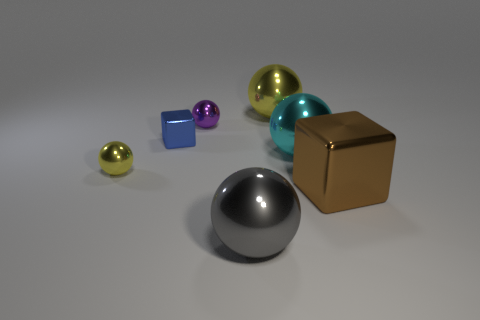The small ball in front of the metal cube left of the purple ball is what color?
Give a very brief answer. Yellow. How many other objects are there of the same material as the big gray object?
Your answer should be very brief. 6. What number of shiny things are small brown cylinders or balls?
Provide a short and direct response. 5. The other shiny object that is the same shape as the blue object is what color?
Your answer should be compact. Brown. How many objects are either small blue objects or big yellow metal things?
Your answer should be very brief. 2. What shape is the cyan thing that is the same material as the big gray sphere?
Provide a short and direct response. Sphere. What number of large objects are either blue spheres or blue metal things?
Your answer should be very brief. 0. How many other objects are the same color as the big metallic block?
Offer a terse response. 0. How many gray metal spheres are left of the metal block that is to the right of the shiny thing that is in front of the brown cube?
Make the answer very short. 1. There is a metal ball that is in front of the brown metallic cube; is its size the same as the cyan sphere?
Ensure brevity in your answer.  Yes. 